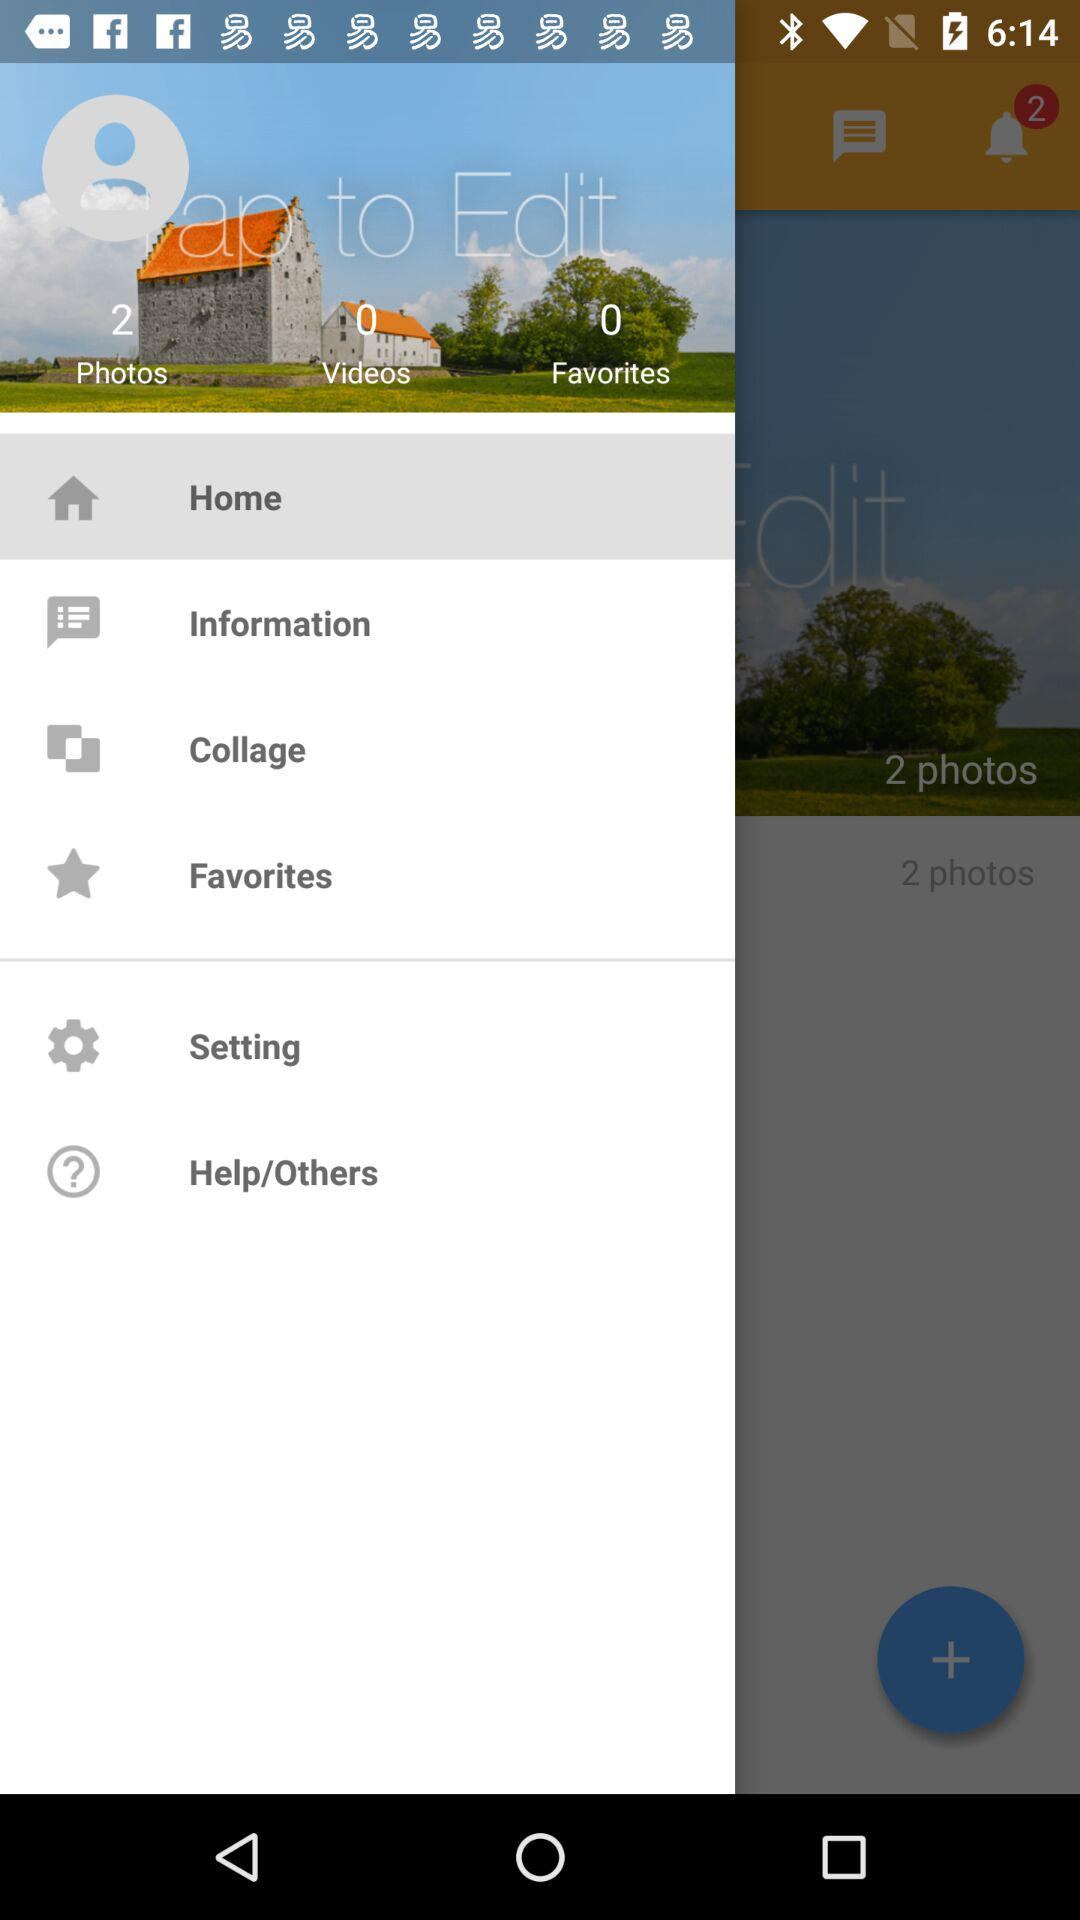How many "Favorites" exist? There are 0 "Favorites" that exist. 